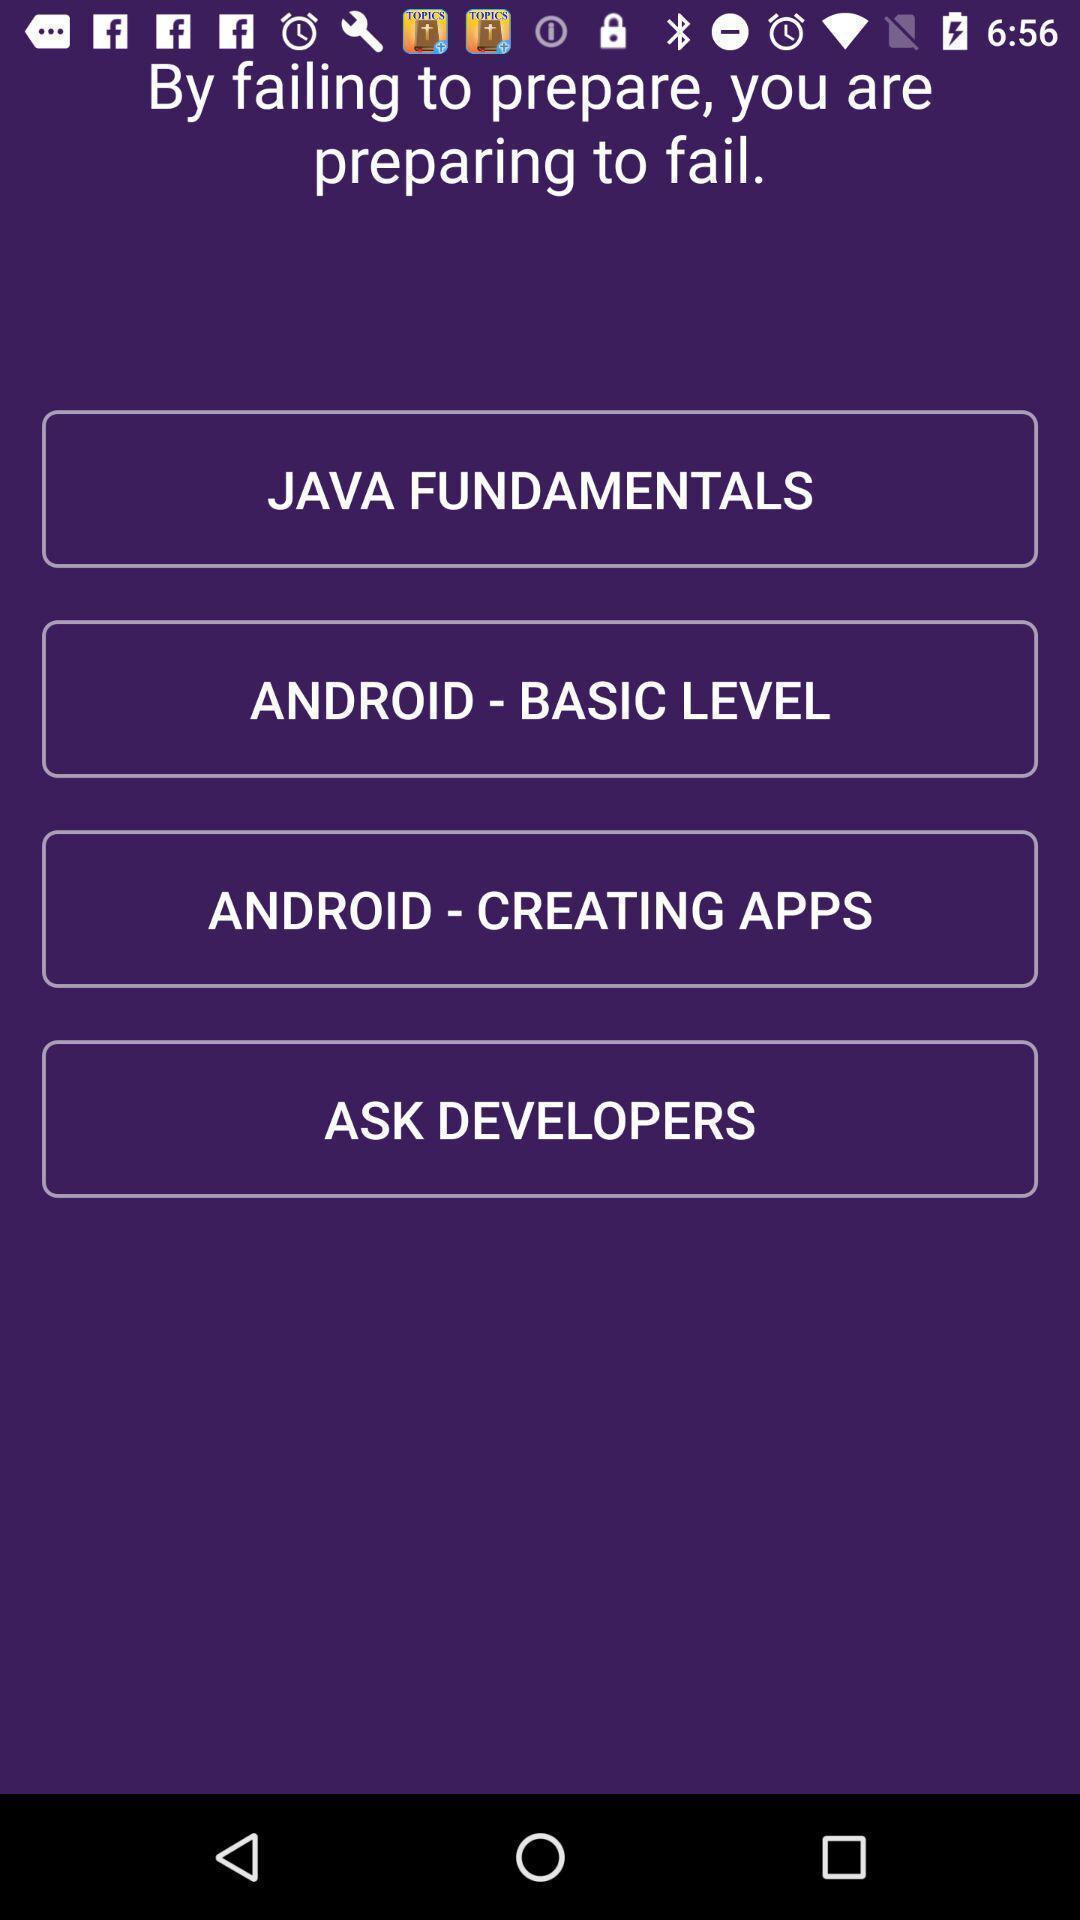Please provide a description for this image. Screen page of a learning application. 